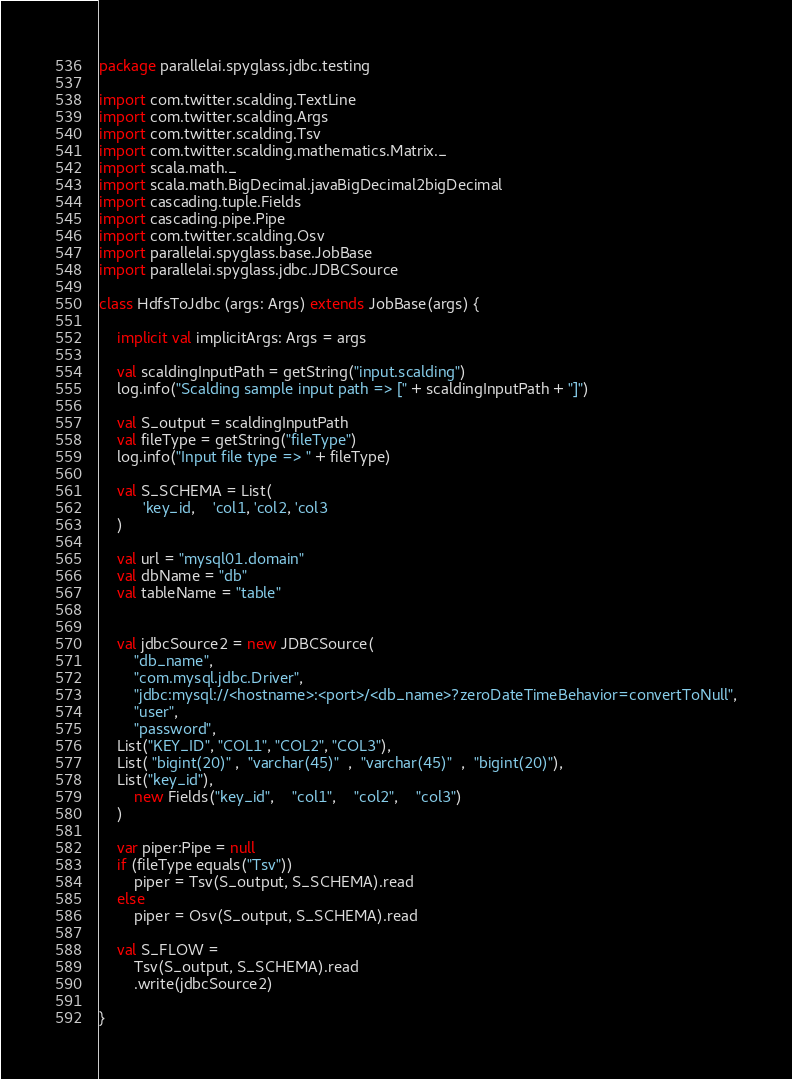<code> <loc_0><loc_0><loc_500><loc_500><_Scala_>package parallelai.spyglass.jdbc.testing

import com.twitter.scalding.TextLine
import com.twitter.scalding.Args
import com.twitter.scalding.Tsv
import com.twitter.scalding.mathematics.Matrix._
import scala.math._
import scala.math.BigDecimal.javaBigDecimal2bigDecimal
import cascading.tuple.Fields
import cascading.pipe.Pipe
import com.twitter.scalding.Osv
import parallelai.spyglass.base.JobBase
import parallelai.spyglass.jdbc.JDBCSource

class HdfsToJdbc (args: Args) extends JobBase(args) { 

	implicit val implicitArgs: Args = args
  
    val scaldingInputPath = getString("input.scalding")  
    log.info("Scalding sample input path => [" + scaldingInputPath + "]")
  
    val S_output = scaldingInputPath
    val fileType = getString("fileType")
    log.info("Input file type => " + fileType)
  
    val S_SCHEMA = List(
		  'key_id,    'col1, 'col2, 'col3
    )  
    	
	val url = "mysql01.domain"
	val dbName = "db"
	val tableName = "table"
	
	  
	val jdbcSource2 = new JDBCSource(
		"db_name",
		"com.mysql.jdbc.Driver",
		"jdbc:mysql://<hostname>:<port>/<db_name>?zeroDateTimeBehavior=convertToNull",
		"user",
		"password",
    List("KEY_ID", "COL1", "COL2", "COL3"),
    List( "bigint(20)" ,  "varchar(45)"  ,  "varchar(45)"  ,  "bigint(20)"),
    List("key_id"),
		new Fields("key_id",    "col1",    "col2",    "col3")
	)
  
    var piper:Pipe = null
    if (fileType equals("Tsv"))
    	piper = Tsv(S_output, S_SCHEMA).read
    else
    	piper = Osv(S_output, S_SCHEMA).read
	   
	val S_FLOW = 
    	Tsv(S_output, S_SCHEMA).read
    	.write(jdbcSource2)

}</code> 